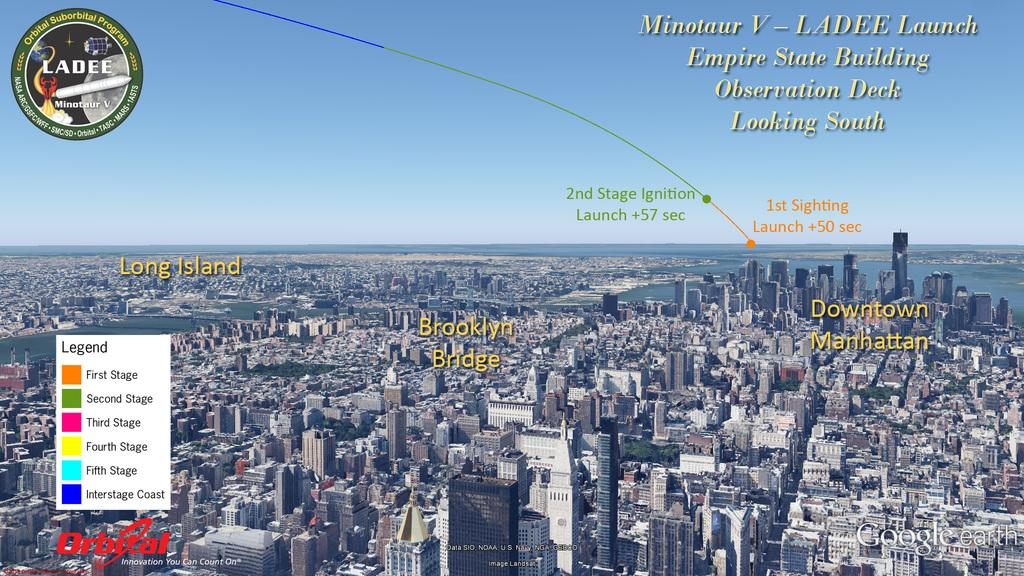What type of view is shown in the image? The image is a top view of a city. What structures can be seen in the image? There are buildings in the image. What natural element is visible in the image? There is water visible in the image. Are there any text or logos present in the image? Yes, there are text and logos on the image. Can you see the lead in the image? There is no lead visible in the image. What type of smile can be seen on the buildings in the image? Buildings do not have the ability to smile, so there are no smiles present in the image. 